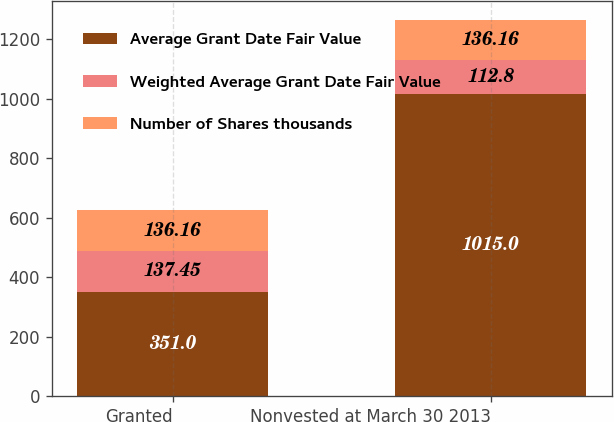<chart> <loc_0><loc_0><loc_500><loc_500><stacked_bar_chart><ecel><fcel>Granted<fcel>Nonvested at March 30 2013<nl><fcel>Average Grant Date Fair Value<fcel>351<fcel>1015<nl><fcel>Weighted Average Grant Date Fair Value<fcel>137.45<fcel>112.8<nl><fcel>Number of Shares thousands<fcel>136.16<fcel>136.16<nl></chart> 